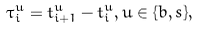<formula> <loc_0><loc_0><loc_500><loc_500>\tau ^ { u } _ { i } = t ^ { u } _ { i + 1 } - t ^ { u } _ { i } , u \in \{ b , s \} ,</formula> 